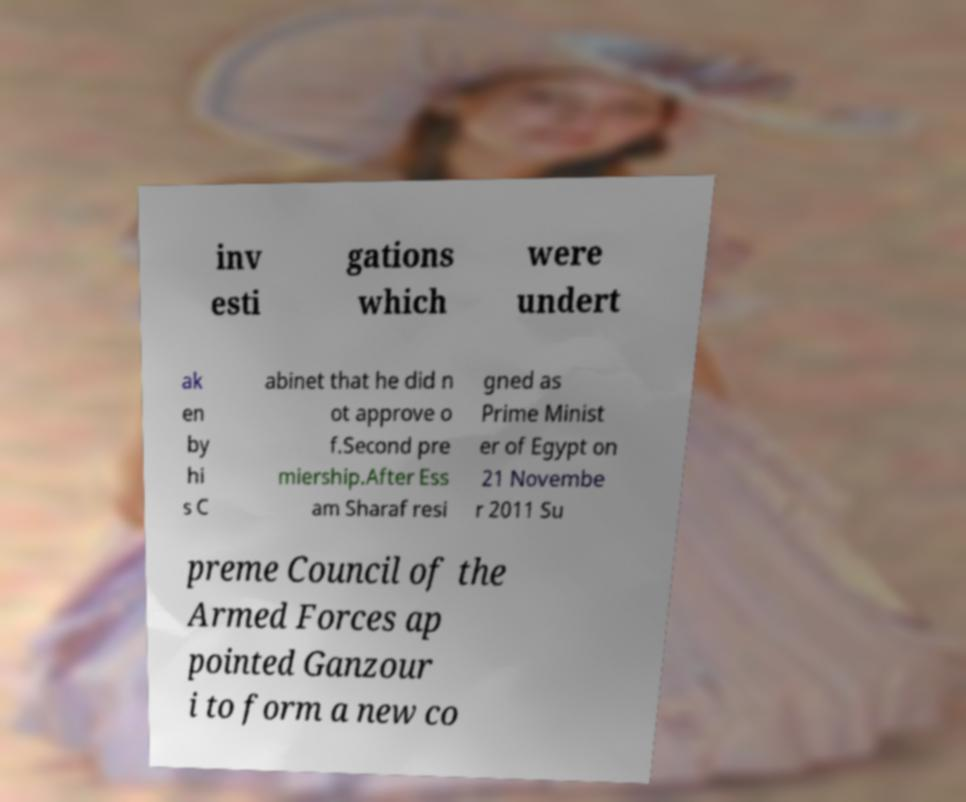What messages or text are displayed in this image? I need them in a readable, typed format. inv esti gations which were undert ak en by hi s C abinet that he did n ot approve o f.Second pre miership.After Ess am Sharaf resi gned as Prime Minist er of Egypt on 21 Novembe r 2011 Su preme Council of the Armed Forces ap pointed Ganzour i to form a new co 